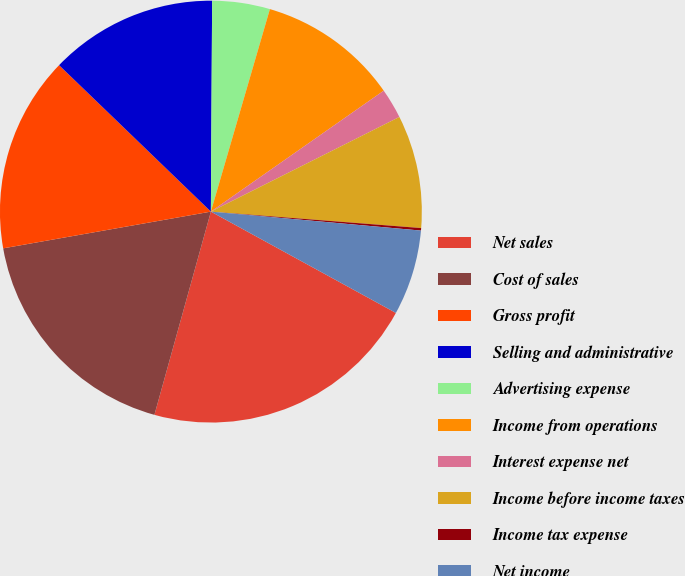Convert chart to OTSL. <chart><loc_0><loc_0><loc_500><loc_500><pie_chart><fcel>Net sales<fcel>Cost of sales<fcel>Gross profit<fcel>Selling and administrative<fcel>Advertising expense<fcel>Income from operations<fcel>Interest expense net<fcel>Income before income taxes<fcel>Income tax expense<fcel>Net income<nl><fcel>21.34%<fcel>17.9%<fcel>15.0%<fcel>12.88%<fcel>4.42%<fcel>10.77%<fcel>2.31%<fcel>8.65%<fcel>0.19%<fcel>6.54%<nl></chart> 